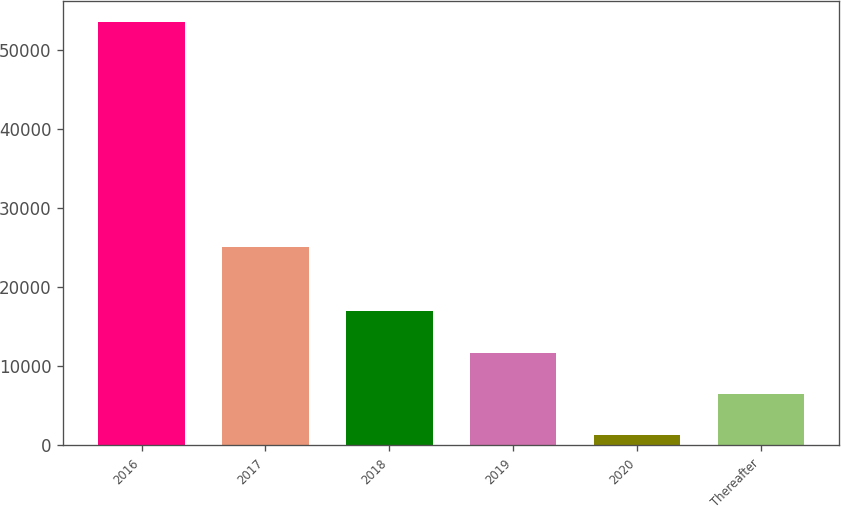Convert chart. <chart><loc_0><loc_0><loc_500><loc_500><bar_chart><fcel>2016<fcel>2017<fcel>2018<fcel>2019<fcel>2020<fcel>Thereafter<nl><fcel>53494<fcel>25114<fcel>16928.8<fcel>11705.2<fcel>1258<fcel>6481.6<nl></chart> 